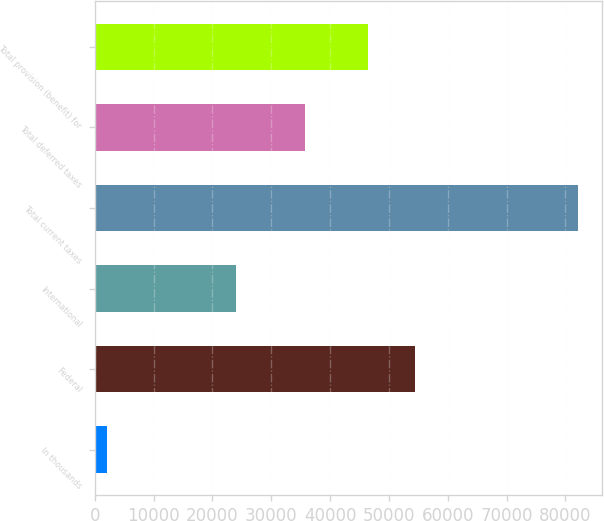<chart> <loc_0><loc_0><loc_500><loc_500><bar_chart><fcel>In thousands<fcel>Federal<fcel>International<fcel>Total current taxes<fcel>Total deferred taxes<fcel>Total provision (benefit) for<nl><fcel>2011<fcel>54430.2<fcel>24005<fcel>82143<fcel>35726<fcel>46417<nl></chart> 